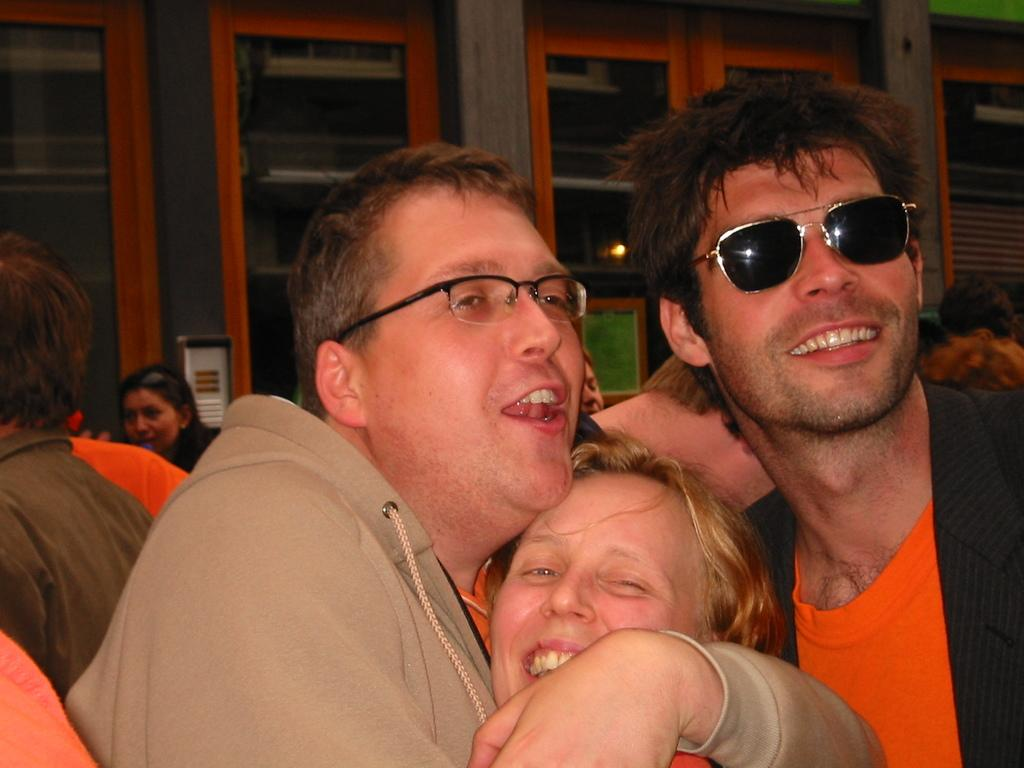How many people are in the image? There are people in the image, but the exact number is not specified. What can be observed about the appearance of some of the people? Two of the people are wearing spectacles. What architectural features can be seen in the background of the image? There are pillars and windows in the background of the image. What type of umbrella is being used by the person in the image? There is no umbrella present in the image. How many fingers does the person with spectacles have on their left hand? The number of fingers on the person's left hand is not visible or mentioned in the image. 